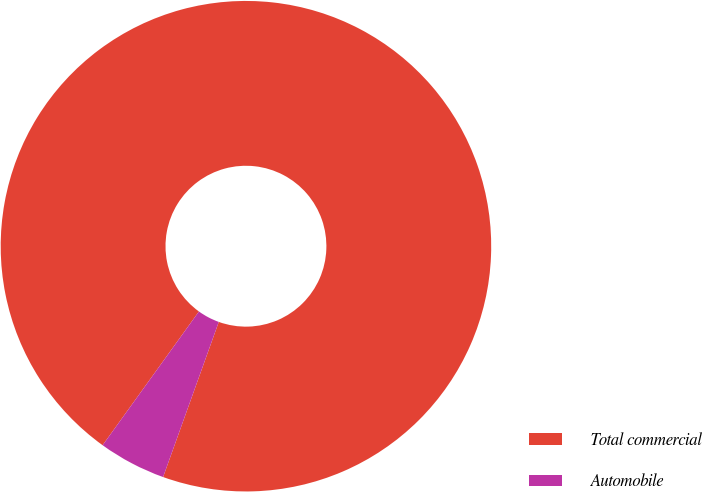Convert chart. <chart><loc_0><loc_0><loc_500><loc_500><pie_chart><fcel>Total commercial<fcel>Automobile<nl><fcel>95.55%<fcel>4.45%<nl></chart> 